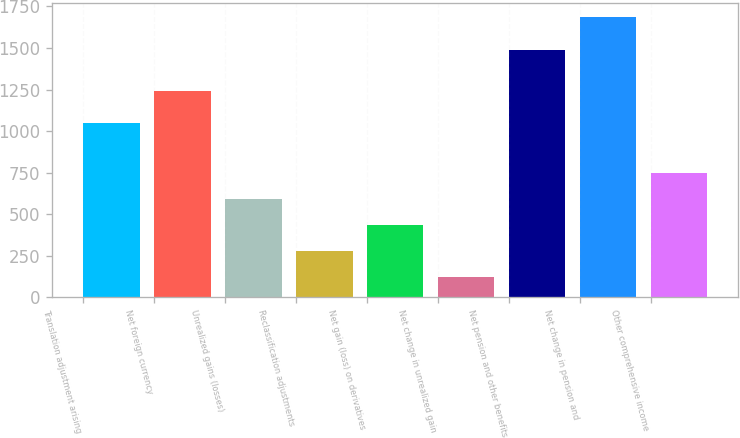Convert chart to OTSL. <chart><loc_0><loc_0><loc_500><loc_500><bar_chart><fcel>Translation adjustment arising<fcel>Net foreign currency<fcel>Unrealized gains (losses)<fcel>Reclassification adjustments<fcel>Net gain (loss) on derivatives<fcel>Net change in unrealized gain<fcel>Net pension and other benefits<fcel>Net change in pension and<fcel>Other comprehensive income<nl><fcel>1046<fcel>1240<fcel>591.8<fcel>278.6<fcel>435.2<fcel>122<fcel>1490<fcel>1688<fcel>748.4<nl></chart> 